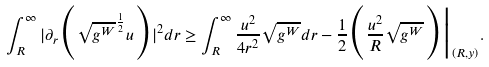Convert formula to latex. <formula><loc_0><loc_0><loc_500><loc_500>\int _ { R } ^ { \infty } | \partial _ { r } \Big { ( } \sqrt { g ^ { W } } ^ { \frac { 1 } { 2 } } u \Big { ) } | ^ { 2 } d r \geq \int _ { R } ^ { \infty } \frac { u ^ { 2 } } { 4 r ^ { 2 } } \sqrt { g ^ { W } } d r - \frac { 1 } { 2 } \Big { ( } \frac { u ^ { 2 } } { R } \sqrt { g ^ { W } } \Big { ) } \Big { | } _ { ( R , y ) } .</formula> 